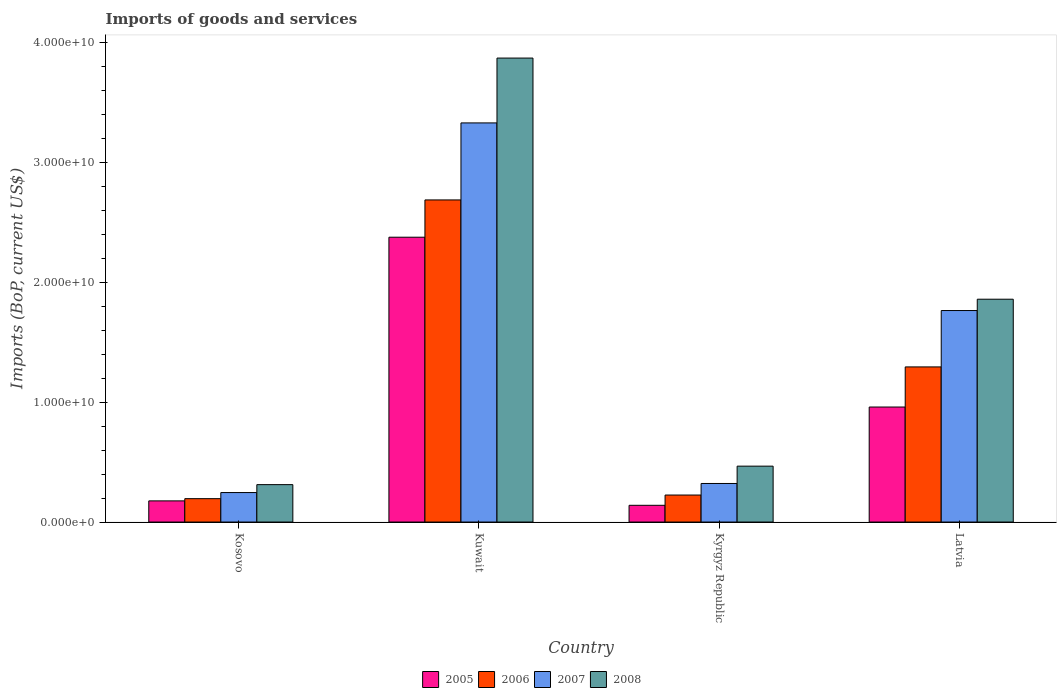How many different coloured bars are there?
Keep it short and to the point. 4. Are the number of bars per tick equal to the number of legend labels?
Offer a terse response. Yes. What is the label of the 4th group of bars from the left?
Ensure brevity in your answer.  Latvia. What is the amount spent on imports in 2007 in Latvia?
Ensure brevity in your answer.  1.76e+1. Across all countries, what is the maximum amount spent on imports in 2005?
Offer a very short reply. 2.38e+1. Across all countries, what is the minimum amount spent on imports in 2005?
Your response must be concise. 1.40e+09. In which country was the amount spent on imports in 2006 maximum?
Ensure brevity in your answer.  Kuwait. In which country was the amount spent on imports in 2008 minimum?
Give a very brief answer. Kosovo. What is the total amount spent on imports in 2007 in the graph?
Make the answer very short. 5.66e+1. What is the difference between the amount spent on imports in 2008 in Kuwait and that in Kyrgyz Republic?
Provide a short and direct response. 3.41e+1. What is the difference between the amount spent on imports in 2008 in Latvia and the amount spent on imports in 2006 in Kosovo?
Your response must be concise. 1.66e+1. What is the average amount spent on imports in 2005 per country?
Your response must be concise. 9.13e+09. What is the difference between the amount spent on imports of/in 2005 and amount spent on imports of/in 2007 in Kyrgyz Republic?
Your response must be concise. -1.82e+09. What is the ratio of the amount spent on imports in 2008 in Kuwait to that in Latvia?
Your response must be concise. 2.08. Is the amount spent on imports in 2008 in Kosovo less than that in Kyrgyz Republic?
Your response must be concise. Yes. Is the difference between the amount spent on imports in 2005 in Kuwait and Kyrgyz Republic greater than the difference between the amount spent on imports in 2007 in Kuwait and Kyrgyz Republic?
Provide a succinct answer. No. What is the difference between the highest and the second highest amount spent on imports in 2006?
Your answer should be compact. 1.07e+1. What is the difference between the highest and the lowest amount spent on imports in 2006?
Give a very brief answer. 2.49e+1. In how many countries, is the amount spent on imports in 2005 greater than the average amount spent on imports in 2005 taken over all countries?
Give a very brief answer. 2. Is the sum of the amount spent on imports in 2007 in Kosovo and Kyrgyz Republic greater than the maximum amount spent on imports in 2006 across all countries?
Make the answer very short. No. Is it the case that in every country, the sum of the amount spent on imports in 2008 and amount spent on imports in 2005 is greater than the sum of amount spent on imports in 2006 and amount spent on imports in 2007?
Provide a short and direct response. No. What does the 4th bar from the right in Kuwait represents?
Give a very brief answer. 2005. Is it the case that in every country, the sum of the amount spent on imports in 2005 and amount spent on imports in 2006 is greater than the amount spent on imports in 2008?
Provide a succinct answer. No. Are all the bars in the graph horizontal?
Ensure brevity in your answer.  No. How many countries are there in the graph?
Make the answer very short. 4. Are the values on the major ticks of Y-axis written in scientific E-notation?
Your response must be concise. Yes. Where does the legend appear in the graph?
Your response must be concise. Bottom center. How are the legend labels stacked?
Your answer should be very brief. Horizontal. What is the title of the graph?
Ensure brevity in your answer.  Imports of goods and services. Does "1991" appear as one of the legend labels in the graph?
Offer a very short reply. No. What is the label or title of the Y-axis?
Your response must be concise. Imports (BoP, current US$). What is the Imports (BoP, current US$) of 2005 in Kosovo?
Offer a very short reply. 1.76e+09. What is the Imports (BoP, current US$) of 2006 in Kosovo?
Your answer should be very brief. 1.95e+09. What is the Imports (BoP, current US$) in 2007 in Kosovo?
Ensure brevity in your answer.  2.46e+09. What is the Imports (BoP, current US$) in 2008 in Kosovo?
Ensure brevity in your answer.  3.12e+09. What is the Imports (BoP, current US$) in 2005 in Kuwait?
Give a very brief answer. 2.38e+1. What is the Imports (BoP, current US$) of 2006 in Kuwait?
Offer a terse response. 2.69e+1. What is the Imports (BoP, current US$) in 2007 in Kuwait?
Keep it short and to the point. 3.33e+1. What is the Imports (BoP, current US$) of 2008 in Kuwait?
Offer a terse response. 3.87e+1. What is the Imports (BoP, current US$) of 2005 in Kyrgyz Republic?
Ensure brevity in your answer.  1.40e+09. What is the Imports (BoP, current US$) in 2006 in Kyrgyz Republic?
Your answer should be very brief. 2.25e+09. What is the Imports (BoP, current US$) of 2007 in Kyrgyz Republic?
Keep it short and to the point. 3.22e+09. What is the Imports (BoP, current US$) of 2008 in Kyrgyz Republic?
Your answer should be very brief. 4.66e+09. What is the Imports (BoP, current US$) of 2005 in Latvia?
Your response must be concise. 9.60e+09. What is the Imports (BoP, current US$) in 2006 in Latvia?
Provide a short and direct response. 1.29e+1. What is the Imports (BoP, current US$) in 2007 in Latvia?
Offer a terse response. 1.76e+1. What is the Imports (BoP, current US$) of 2008 in Latvia?
Offer a terse response. 1.86e+1. Across all countries, what is the maximum Imports (BoP, current US$) of 2005?
Ensure brevity in your answer.  2.38e+1. Across all countries, what is the maximum Imports (BoP, current US$) in 2006?
Your answer should be compact. 2.69e+1. Across all countries, what is the maximum Imports (BoP, current US$) in 2007?
Make the answer very short. 3.33e+1. Across all countries, what is the maximum Imports (BoP, current US$) of 2008?
Ensure brevity in your answer.  3.87e+1. Across all countries, what is the minimum Imports (BoP, current US$) in 2005?
Provide a succinct answer. 1.40e+09. Across all countries, what is the minimum Imports (BoP, current US$) in 2006?
Offer a very short reply. 1.95e+09. Across all countries, what is the minimum Imports (BoP, current US$) of 2007?
Offer a very short reply. 2.46e+09. Across all countries, what is the minimum Imports (BoP, current US$) of 2008?
Provide a short and direct response. 3.12e+09. What is the total Imports (BoP, current US$) of 2005 in the graph?
Ensure brevity in your answer.  3.65e+1. What is the total Imports (BoP, current US$) of 2006 in the graph?
Offer a very short reply. 4.40e+1. What is the total Imports (BoP, current US$) of 2007 in the graph?
Give a very brief answer. 5.66e+1. What is the total Imports (BoP, current US$) of 2008 in the graph?
Offer a terse response. 6.51e+1. What is the difference between the Imports (BoP, current US$) of 2005 in Kosovo and that in Kuwait?
Offer a very short reply. -2.20e+1. What is the difference between the Imports (BoP, current US$) in 2006 in Kosovo and that in Kuwait?
Your answer should be compact. -2.49e+1. What is the difference between the Imports (BoP, current US$) of 2007 in Kosovo and that in Kuwait?
Offer a very short reply. -3.08e+1. What is the difference between the Imports (BoP, current US$) of 2008 in Kosovo and that in Kuwait?
Give a very brief answer. -3.56e+1. What is the difference between the Imports (BoP, current US$) in 2005 in Kosovo and that in Kyrgyz Republic?
Make the answer very short. 3.69e+08. What is the difference between the Imports (BoP, current US$) in 2006 in Kosovo and that in Kyrgyz Republic?
Ensure brevity in your answer.  -3.02e+08. What is the difference between the Imports (BoP, current US$) of 2007 in Kosovo and that in Kyrgyz Republic?
Offer a terse response. -7.58e+08. What is the difference between the Imports (BoP, current US$) of 2008 in Kosovo and that in Kyrgyz Republic?
Ensure brevity in your answer.  -1.54e+09. What is the difference between the Imports (BoP, current US$) in 2005 in Kosovo and that in Latvia?
Your answer should be very brief. -7.83e+09. What is the difference between the Imports (BoP, current US$) in 2006 in Kosovo and that in Latvia?
Ensure brevity in your answer.  -1.10e+1. What is the difference between the Imports (BoP, current US$) in 2007 in Kosovo and that in Latvia?
Ensure brevity in your answer.  -1.52e+1. What is the difference between the Imports (BoP, current US$) of 2008 in Kosovo and that in Latvia?
Ensure brevity in your answer.  -1.55e+1. What is the difference between the Imports (BoP, current US$) in 2005 in Kuwait and that in Kyrgyz Republic?
Your response must be concise. 2.24e+1. What is the difference between the Imports (BoP, current US$) of 2006 in Kuwait and that in Kyrgyz Republic?
Ensure brevity in your answer.  2.46e+1. What is the difference between the Imports (BoP, current US$) in 2007 in Kuwait and that in Kyrgyz Republic?
Ensure brevity in your answer.  3.01e+1. What is the difference between the Imports (BoP, current US$) in 2008 in Kuwait and that in Kyrgyz Republic?
Provide a short and direct response. 3.41e+1. What is the difference between the Imports (BoP, current US$) of 2005 in Kuwait and that in Latvia?
Ensure brevity in your answer.  1.42e+1. What is the difference between the Imports (BoP, current US$) in 2006 in Kuwait and that in Latvia?
Your response must be concise. 1.39e+1. What is the difference between the Imports (BoP, current US$) in 2007 in Kuwait and that in Latvia?
Provide a succinct answer. 1.57e+1. What is the difference between the Imports (BoP, current US$) in 2008 in Kuwait and that in Latvia?
Your answer should be very brief. 2.01e+1. What is the difference between the Imports (BoP, current US$) of 2005 in Kyrgyz Republic and that in Latvia?
Offer a terse response. -8.20e+09. What is the difference between the Imports (BoP, current US$) of 2006 in Kyrgyz Republic and that in Latvia?
Your answer should be compact. -1.07e+1. What is the difference between the Imports (BoP, current US$) of 2007 in Kyrgyz Republic and that in Latvia?
Ensure brevity in your answer.  -1.44e+1. What is the difference between the Imports (BoP, current US$) of 2008 in Kyrgyz Republic and that in Latvia?
Make the answer very short. -1.39e+1. What is the difference between the Imports (BoP, current US$) of 2005 in Kosovo and the Imports (BoP, current US$) of 2006 in Kuwait?
Provide a succinct answer. -2.51e+1. What is the difference between the Imports (BoP, current US$) in 2005 in Kosovo and the Imports (BoP, current US$) in 2007 in Kuwait?
Offer a very short reply. -3.15e+1. What is the difference between the Imports (BoP, current US$) in 2005 in Kosovo and the Imports (BoP, current US$) in 2008 in Kuwait?
Your response must be concise. -3.70e+1. What is the difference between the Imports (BoP, current US$) in 2006 in Kosovo and the Imports (BoP, current US$) in 2007 in Kuwait?
Your answer should be compact. -3.14e+1. What is the difference between the Imports (BoP, current US$) in 2006 in Kosovo and the Imports (BoP, current US$) in 2008 in Kuwait?
Ensure brevity in your answer.  -3.68e+1. What is the difference between the Imports (BoP, current US$) of 2007 in Kosovo and the Imports (BoP, current US$) of 2008 in Kuwait?
Offer a very short reply. -3.63e+1. What is the difference between the Imports (BoP, current US$) in 2005 in Kosovo and the Imports (BoP, current US$) in 2006 in Kyrgyz Republic?
Offer a terse response. -4.88e+08. What is the difference between the Imports (BoP, current US$) in 2005 in Kosovo and the Imports (BoP, current US$) in 2007 in Kyrgyz Republic?
Ensure brevity in your answer.  -1.45e+09. What is the difference between the Imports (BoP, current US$) in 2005 in Kosovo and the Imports (BoP, current US$) in 2008 in Kyrgyz Republic?
Offer a terse response. -2.90e+09. What is the difference between the Imports (BoP, current US$) in 2006 in Kosovo and the Imports (BoP, current US$) in 2007 in Kyrgyz Republic?
Offer a very short reply. -1.27e+09. What is the difference between the Imports (BoP, current US$) in 2006 in Kosovo and the Imports (BoP, current US$) in 2008 in Kyrgyz Republic?
Provide a short and direct response. -2.71e+09. What is the difference between the Imports (BoP, current US$) of 2007 in Kosovo and the Imports (BoP, current US$) of 2008 in Kyrgyz Republic?
Your answer should be very brief. -2.20e+09. What is the difference between the Imports (BoP, current US$) of 2005 in Kosovo and the Imports (BoP, current US$) of 2006 in Latvia?
Keep it short and to the point. -1.12e+1. What is the difference between the Imports (BoP, current US$) in 2005 in Kosovo and the Imports (BoP, current US$) in 2007 in Latvia?
Give a very brief answer. -1.59e+1. What is the difference between the Imports (BoP, current US$) in 2005 in Kosovo and the Imports (BoP, current US$) in 2008 in Latvia?
Your answer should be very brief. -1.68e+1. What is the difference between the Imports (BoP, current US$) of 2006 in Kosovo and the Imports (BoP, current US$) of 2007 in Latvia?
Your answer should be compact. -1.57e+1. What is the difference between the Imports (BoP, current US$) of 2006 in Kosovo and the Imports (BoP, current US$) of 2008 in Latvia?
Your answer should be very brief. -1.66e+1. What is the difference between the Imports (BoP, current US$) of 2007 in Kosovo and the Imports (BoP, current US$) of 2008 in Latvia?
Your answer should be compact. -1.61e+1. What is the difference between the Imports (BoP, current US$) of 2005 in Kuwait and the Imports (BoP, current US$) of 2006 in Kyrgyz Republic?
Offer a very short reply. 2.15e+1. What is the difference between the Imports (BoP, current US$) in 2005 in Kuwait and the Imports (BoP, current US$) in 2007 in Kyrgyz Republic?
Give a very brief answer. 2.06e+1. What is the difference between the Imports (BoP, current US$) in 2005 in Kuwait and the Imports (BoP, current US$) in 2008 in Kyrgyz Republic?
Your answer should be compact. 1.91e+1. What is the difference between the Imports (BoP, current US$) of 2006 in Kuwait and the Imports (BoP, current US$) of 2007 in Kyrgyz Republic?
Your answer should be compact. 2.37e+1. What is the difference between the Imports (BoP, current US$) of 2006 in Kuwait and the Imports (BoP, current US$) of 2008 in Kyrgyz Republic?
Ensure brevity in your answer.  2.22e+1. What is the difference between the Imports (BoP, current US$) in 2007 in Kuwait and the Imports (BoP, current US$) in 2008 in Kyrgyz Republic?
Keep it short and to the point. 2.86e+1. What is the difference between the Imports (BoP, current US$) of 2005 in Kuwait and the Imports (BoP, current US$) of 2006 in Latvia?
Offer a terse response. 1.08e+1. What is the difference between the Imports (BoP, current US$) in 2005 in Kuwait and the Imports (BoP, current US$) in 2007 in Latvia?
Give a very brief answer. 6.12e+09. What is the difference between the Imports (BoP, current US$) in 2005 in Kuwait and the Imports (BoP, current US$) in 2008 in Latvia?
Give a very brief answer. 5.17e+09. What is the difference between the Imports (BoP, current US$) of 2006 in Kuwait and the Imports (BoP, current US$) of 2007 in Latvia?
Give a very brief answer. 9.23e+09. What is the difference between the Imports (BoP, current US$) of 2006 in Kuwait and the Imports (BoP, current US$) of 2008 in Latvia?
Your answer should be very brief. 8.28e+09. What is the difference between the Imports (BoP, current US$) of 2007 in Kuwait and the Imports (BoP, current US$) of 2008 in Latvia?
Your answer should be compact. 1.47e+1. What is the difference between the Imports (BoP, current US$) in 2005 in Kyrgyz Republic and the Imports (BoP, current US$) in 2006 in Latvia?
Make the answer very short. -1.15e+1. What is the difference between the Imports (BoP, current US$) of 2005 in Kyrgyz Republic and the Imports (BoP, current US$) of 2007 in Latvia?
Make the answer very short. -1.63e+1. What is the difference between the Imports (BoP, current US$) of 2005 in Kyrgyz Republic and the Imports (BoP, current US$) of 2008 in Latvia?
Your answer should be compact. -1.72e+1. What is the difference between the Imports (BoP, current US$) of 2006 in Kyrgyz Republic and the Imports (BoP, current US$) of 2007 in Latvia?
Offer a terse response. -1.54e+1. What is the difference between the Imports (BoP, current US$) of 2006 in Kyrgyz Republic and the Imports (BoP, current US$) of 2008 in Latvia?
Ensure brevity in your answer.  -1.63e+1. What is the difference between the Imports (BoP, current US$) in 2007 in Kyrgyz Republic and the Imports (BoP, current US$) in 2008 in Latvia?
Ensure brevity in your answer.  -1.54e+1. What is the average Imports (BoP, current US$) of 2005 per country?
Your answer should be very brief. 9.13e+09. What is the average Imports (BoP, current US$) in 2006 per country?
Your response must be concise. 1.10e+1. What is the average Imports (BoP, current US$) of 2007 per country?
Your response must be concise. 1.42e+1. What is the average Imports (BoP, current US$) in 2008 per country?
Ensure brevity in your answer.  1.63e+1. What is the difference between the Imports (BoP, current US$) of 2005 and Imports (BoP, current US$) of 2006 in Kosovo?
Offer a terse response. -1.86e+08. What is the difference between the Imports (BoP, current US$) in 2005 and Imports (BoP, current US$) in 2007 in Kosovo?
Offer a very short reply. -6.96e+08. What is the difference between the Imports (BoP, current US$) of 2005 and Imports (BoP, current US$) of 2008 in Kosovo?
Your answer should be compact. -1.36e+09. What is the difference between the Imports (BoP, current US$) of 2006 and Imports (BoP, current US$) of 2007 in Kosovo?
Keep it short and to the point. -5.10e+08. What is the difference between the Imports (BoP, current US$) in 2006 and Imports (BoP, current US$) in 2008 in Kosovo?
Your response must be concise. -1.17e+09. What is the difference between the Imports (BoP, current US$) in 2007 and Imports (BoP, current US$) in 2008 in Kosovo?
Provide a succinct answer. -6.61e+08. What is the difference between the Imports (BoP, current US$) in 2005 and Imports (BoP, current US$) in 2006 in Kuwait?
Your answer should be very brief. -3.11e+09. What is the difference between the Imports (BoP, current US$) of 2005 and Imports (BoP, current US$) of 2007 in Kuwait?
Your response must be concise. -9.54e+09. What is the difference between the Imports (BoP, current US$) of 2005 and Imports (BoP, current US$) of 2008 in Kuwait?
Keep it short and to the point. -1.49e+1. What is the difference between the Imports (BoP, current US$) of 2006 and Imports (BoP, current US$) of 2007 in Kuwait?
Offer a terse response. -6.43e+09. What is the difference between the Imports (BoP, current US$) of 2006 and Imports (BoP, current US$) of 2008 in Kuwait?
Make the answer very short. -1.18e+1. What is the difference between the Imports (BoP, current US$) of 2007 and Imports (BoP, current US$) of 2008 in Kuwait?
Give a very brief answer. -5.41e+09. What is the difference between the Imports (BoP, current US$) of 2005 and Imports (BoP, current US$) of 2006 in Kyrgyz Republic?
Ensure brevity in your answer.  -8.56e+08. What is the difference between the Imports (BoP, current US$) in 2005 and Imports (BoP, current US$) in 2007 in Kyrgyz Republic?
Keep it short and to the point. -1.82e+09. What is the difference between the Imports (BoP, current US$) of 2005 and Imports (BoP, current US$) of 2008 in Kyrgyz Republic?
Ensure brevity in your answer.  -3.27e+09. What is the difference between the Imports (BoP, current US$) in 2006 and Imports (BoP, current US$) in 2007 in Kyrgyz Republic?
Provide a short and direct response. -9.66e+08. What is the difference between the Imports (BoP, current US$) in 2006 and Imports (BoP, current US$) in 2008 in Kyrgyz Republic?
Your response must be concise. -2.41e+09. What is the difference between the Imports (BoP, current US$) in 2007 and Imports (BoP, current US$) in 2008 in Kyrgyz Republic?
Ensure brevity in your answer.  -1.45e+09. What is the difference between the Imports (BoP, current US$) of 2005 and Imports (BoP, current US$) of 2006 in Latvia?
Your response must be concise. -3.35e+09. What is the difference between the Imports (BoP, current US$) in 2005 and Imports (BoP, current US$) in 2007 in Latvia?
Ensure brevity in your answer.  -8.05e+09. What is the difference between the Imports (BoP, current US$) in 2005 and Imports (BoP, current US$) in 2008 in Latvia?
Make the answer very short. -9.00e+09. What is the difference between the Imports (BoP, current US$) in 2006 and Imports (BoP, current US$) in 2007 in Latvia?
Your answer should be compact. -4.71e+09. What is the difference between the Imports (BoP, current US$) in 2006 and Imports (BoP, current US$) in 2008 in Latvia?
Your answer should be very brief. -5.65e+09. What is the difference between the Imports (BoP, current US$) in 2007 and Imports (BoP, current US$) in 2008 in Latvia?
Your response must be concise. -9.45e+08. What is the ratio of the Imports (BoP, current US$) of 2005 in Kosovo to that in Kuwait?
Provide a short and direct response. 0.07. What is the ratio of the Imports (BoP, current US$) in 2006 in Kosovo to that in Kuwait?
Make the answer very short. 0.07. What is the ratio of the Imports (BoP, current US$) in 2007 in Kosovo to that in Kuwait?
Make the answer very short. 0.07. What is the ratio of the Imports (BoP, current US$) of 2008 in Kosovo to that in Kuwait?
Provide a succinct answer. 0.08. What is the ratio of the Imports (BoP, current US$) in 2005 in Kosovo to that in Kyrgyz Republic?
Give a very brief answer. 1.26. What is the ratio of the Imports (BoP, current US$) of 2006 in Kosovo to that in Kyrgyz Republic?
Your response must be concise. 0.87. What is the ratio of the Imports (BoP, current US$) of 2007 in Kosovo to that in Kyrgyz Republic?
Offer a terse response. 0.76. What is the ratio of the Imports (BoP, current US$) of 2008 in Kosovo to that in Kyrgyz Republic?
Offer a terse response. 0.67. What is the ratio of the Imports (BoP, current US$) of 2005 in Kosovo to that in Latvia?
Offer a terse response. 0.18. What is the ratio of the Imports (BoP, current US$) in 2006 in Kosovo to that in Latvia?
Your answer should be compact. 0.15. What is the ratio of the Imports (BoP, current US$) of 2007 in Kosovo to that in Latvia?
Make the answer very short. 0.14. What is the ratio of the Imports (BoP, current US$) in 2008 in Kosovo to that in Latvia?
Make the answer very short. 0.17. What is the ratio of the Imports (BoP, current US$) in 2005 in Kuwait to that in Kyrgyz Republic?
Provide a succinct answer. 17.03. What is the ratio of the Imports (BoP, current US$) of 2006 in Kuwait to that in Kyrgyz Republic?
Ensure brevity in your answer.  11.93. What is the ratio of the Imports (BoP, current US$) of 2007 in Kuwait to that in Kyrgyz Republic?
Offer a very short reply. 10.35. What is the ratio of the Imports (BoP, current US$) in 2008 in Kuwait to that in Kyrgyz Republic?
Your answer should be very brief. 8.3. What is the ratio of the Imports (BoP, current US$) in 2005 in Kuwait to that in Latvia?
Offer a very short reply. 2.48. What is the ratio of the Imports (BoP, current US$) of 2006 in Kuwait to that in Latvia?
Your answer should be very brief. 2.08. What is the ratio of the Imports (BoP, current US$) of 2007 in Kuwait to that in Latvia?
Provide a short and direct response. 1.89. What is the ratio of the Imports (BoP, current US$) of 2008 in Kuwait to that in Latvia?
Offer a very short reply. 2.08. What is the ratio of the Imports (BoP, current US$) of 2005 in Kyrgyz Republic to that in Latvia?
Provide a short and direct response. 0.15. What is the ratio of the Imports (BoP, current US$) of 2006 in Kyrgyz Republic to that in Latvia?
Keep it short and to the point. 0.17. What is the ratio of the Imports (BoP, current US$) of 2007 in Kyrgyz Republic to that in Latvia?
Your response must be concise. 0.18. What is the ratio of the Imports (BoP, current US$) of 2008 in Kyrgyz Republic to that in Latvia?
Your answer should be compact. 0.25. What is the difference between the highest and the second highest Imports (BoP, current US$) of 2005?
Ensure brevity in your answer.  1.42e+1. What is the difference between the highest and the second highest Imports (BoP, current US$) of 2006?
Your answer should be compact. 1.39e+1. What is the difference between the highest and the second highest Imports (BoP, current US$) in 2007?
Give a very brief answer. 1.57e+1. What is the difference between the highest and the second highest Imports (BoP, current US$) of 2008?
Offer a very short reply. 2.01e+1. What is the difference between the highest and the lowest Imports (BoP, current US$) in 2005?
Your response must be concise. 2.24e+1. What is the difference between the highest and the lowest Imports (BoP, current US$) in 2006?
Offer a very short reply. 2.49e+1. What is the difference between the highest and the lowest Imports (BoP, current US$) in 2007?
Provide a short and direct response. 3.08e+1. What is the difference between the highest and the lowest Imports (BoP, current US$) in 2008?
Your response must be concise. 3.56e+1. 